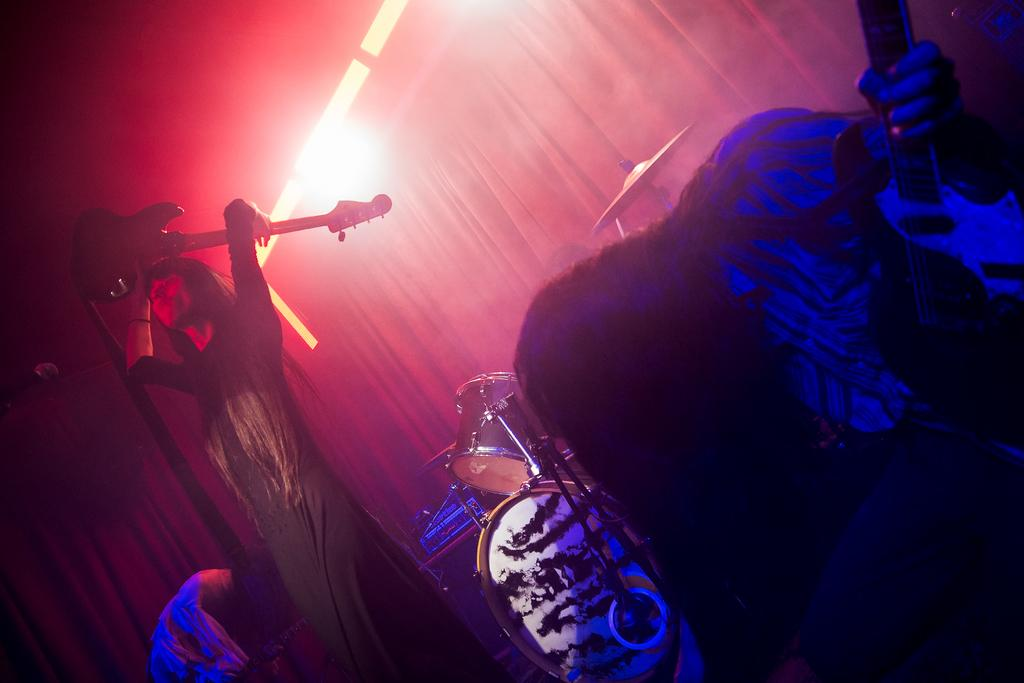What is the person in the image doing? The person is performing in the image. What instrument is the person holding? The person is holding a guitar. Can you describe the lighting in the image? There is a light behind the person. What type of cave can be seen in the background of the image? There is no cave present in the image; it features a person performing with a guitar and a light behind them. 